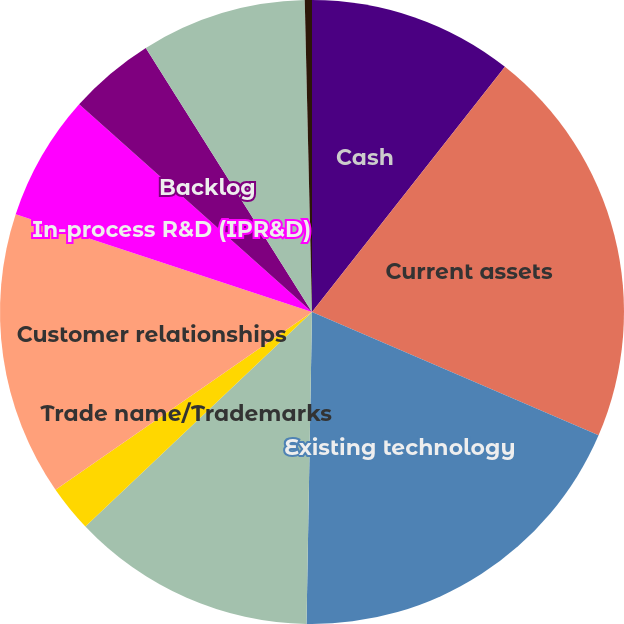<chart> <loc_0><loc_0><loc_500><loc_500><pie_chart><fcel>Cash<fcel>Current assets<fcel>Existing technology<fcel>Patents<fcel>Trade name/Trademarks<fcel>Customer relationships<fcel>In-process R&D (IPR&D)<fcel>Backlog<fcel>Other intangible assets<fcel>Non-current assets<nl><fcel>10.61%<fcel>20.86%<fcel>18.81%<fcel>12.66%<fcel>2.42%<fcel>14.71%<fcel>6.52%<fcel>4.47%<fcel>8.57%<fcel>0.37%<nl></chart> 